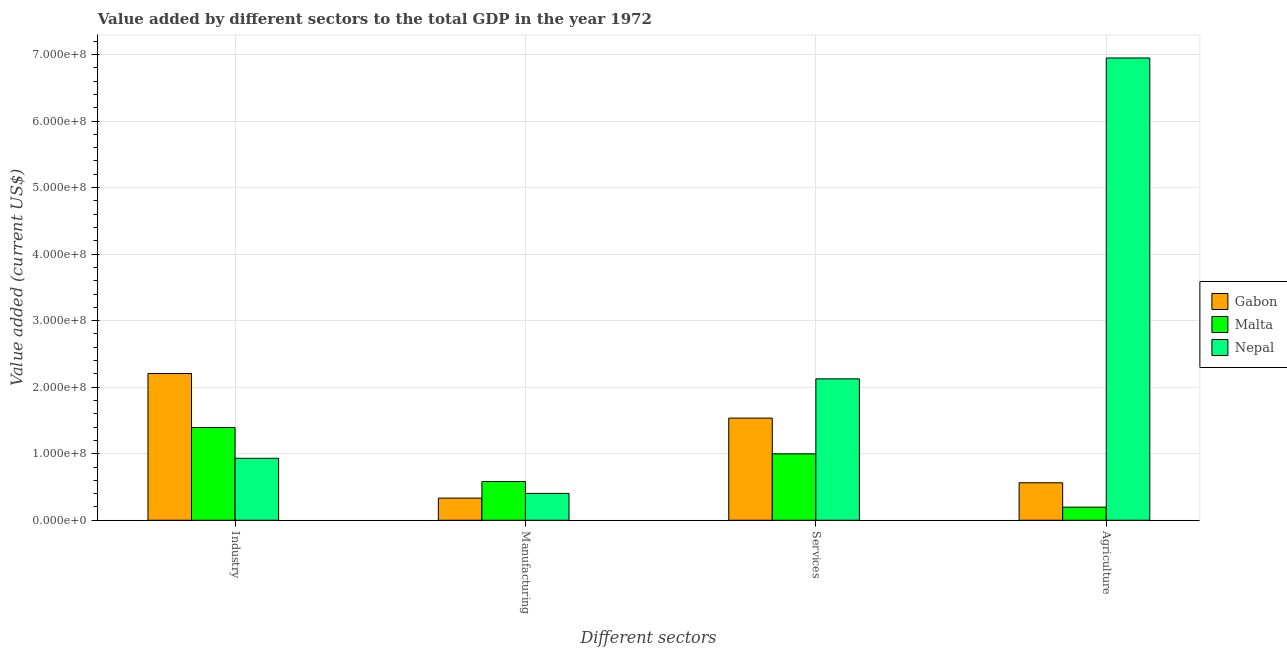Are the number of bars per tick equal to the number of legend labels?
Your response must be concise. Yes. Are the number of bars on each tick of the X-axis equal?
Offer a terse response. Yes. How many bars are there on the 1st tick from the right?
Keep it short and to the point. 3. What is the label of the 3rd group of bars from the left?
Keep it short and to the point. Services. What is the value added by industrial sector in Gabon?
Offer a very short reply. 2.21e+08. Across all countries, what is the maximum value added by services sector?
Your answer should be very brief. 2.13e+08. Across all countries, what is the minimum value added by agricultural sector?
Offer a very short reply. 1.97e+07. In which country was the value added by services sector maximum?
Make the answer very short. Nepal. In which country was the value added by services sector minimum?
Give a very brief answer. Malta. What is the total value added by manufacturing sector in the graph?
Give a very brief answer. 1.32e+08. What is the difference between the value added by manufacturing sector in Malta and that in Gabon?
Keep it short and to the point. 2.49e+07. What is the difference between the value added by manufacturing sector in Gabon and the value added by services sector in Malta?
Your answer should be very brief. -6.65e+07. What is the average value added by services sector per country?
Keep it short and to the point. 1.55e+08. What is the difference between the value added by industrial sector and value added by manufacturing sector in Nepal?
Provide a succinct answer. 5.27e+07. What is the ratio of the value added by manufacturing sector in Gabon to that in Nepal?
Make the answer very short. 0.83. What is the difference between the highest and the second highest value added by industrial sector?
Ensure brevity in your answer.  8.11e+07. What is the difference between the highest and the lowest value added by manufacturing sector?
Ensure brevity in your answer.  2.49e+07. Is the sum of the value added by manufacturing sector in Gabon and Malta greater than the maximum value added by industrial sector across all countries?
Make the answer very short. No. What does the 3rd bar from the left in Agriculture represents?
Keep it short and to the point. Nepal. What does the 2nd bar from the right in Services represents?
Make the answer very short. Malta. Are all the bars in the graph horizontal?
Your answer should be very brief. No. How many countries are there in the graph?
Provide a short and direct response. 3. What is the difference between two consecutive major ticks on the Y-axis?
Keep it short and to the point. 1.00e+08. Where does the legend appear in the graph?
Make the answer very short. Center right. What is the title of the graph?
Provide a succinct answer. Value added by different sectors to the total GDP in the year 1972. Does "Netherlands" appear as one of the legend labels in the graph?
Your answer should be compact. No. What is the label or title of the X-axis?
Your answer should be very brief. Different sectors. What is the label or title of the Y-axis?
Your response must be concise. Value added (current US$). What is the Value added (current US$) in Gabon in Industry?
Provide a short and direct response. 2.21e+08. What is the Value added (current US$) in Malta in Industry?
Provide a short and direct response. 1.39e+08. What is the Value added (current US$) in Nepal in Industry?
Keep it short and to the point. 9.31e+07. What is the Value added (current US$) of Gabon in Manufacturing?
Provide a short and direct response. 3.33e+07. What is the Value added (current US$) of Malta in Manufacturing?
Offer a terse response. 5.83e+07. What is the Value added (current US$) of Nepal in Manufacturing?
Keep it short and to the point. 4.04e+07. What is the Value added (current US$) in Gabon in Services?
Your response must be concise. 1.54e+08. What is the Value added (current US$) in Malta in Services?
Make the answer very short. 9.99e+07. What is the Value added (current US$) in Nepal in Services?
Give a very brief answer. 2.13e+08. What is the Value added (current US$) in Gabon in Agriculture?
Provide a short and direct response. 5.63e+07. What is the Value added (current US$) in Malta in Agriculture?
Offer a very short reply. 1.97e+07. What is the Value added (current US$) in Nepal in Agriculture?
Your response must be concise. 6.95e+08. Across all Different sectors, what is the maximum Value added (current US$) of Gabon?
Keep it short and to the point. 2.21e+08. Across all Different sectors, what is the maximum Value added (current US$) in Malta?
Provide a succinct answer. 1.39e+08. Across all Different sectors, what is the maximum Value added (current US$) in Nepal?
Your answer should be compact. 6.95e+08. Across all Different sectors, what is the minimum Value added (current US$) of Gabon?
Make the answer very short. 3.33e+07. Across all Different sectors, what is the minimum Value added (current US$) of Malta?
Provide a short and direct response. 1.97e+07. Across all Different sectors, what is the minimum Value added (current US$) in Nepal?
Provide a succinct answer. 4.04e+07. What is the total Value added (current US$) in Gabon in the graph?
Offer a very short reply. 4.64e+08. What is the total Value added (current US$) in Malta in the graph?
Offer a terse response. 3.17e+08. What is the total Value added (current US$) in Nepal in the graph?
Provide a short and direct response. 1.04e+09. What is the difference between the Value added (current US$) of Gabon in Industry and that in Manufacturing?
Your answer should be very brief. 1.87e+08. What is the difference between the Value added (current US$) in Malta in Industry and that in Manufacturing?
Provide a succinct answer. 8.12e+07. What is the difference between the Value added (current US$) of Nepal in Industry and that in Manufacturing?
Your answer should be compact. 5.27e+07. What is the difference between the Value added (current US$) in Gabon in Industry and that in Services?
Give a very brief answer. 6.71e+07. What is the difference between the Value added (current US$) of Malta in Industry and that in Services?
Keep it short and to the point. 3.96e+07. What is the difference between the Value added (current US$) of Nepal in Industry and that in Services?
Give a very brief answer. -1.19e+08. What is the difference between the Value added (current US$) of Gabon in Industry and that in Agriculture?
Give a very brief answer. 1.64e+08. What is the difference between the Value added (current US$) in Malta in Industry and that in Agriculture?
Give a very brief answer. 1.20e+08. What is the difference between the Value added (current US$) in Nepal in Industry and that in Agriculture?
Keep it short and to the point. -6.02e+08. What is the difference between the Value added (current US$) in Gabon in Manufacturing and that in Services?
Give a very brief answer. -1.20e+08. What is the difference between the Value added (current US$) of Malta in Manufacturing and that in Services?
Offer a very short reply. -4.16e+07. What is the difference between the Value added (current US$) of Nepal in Manufacturing and that in Services?
Make the answer very short. -1.72e+08. What is the difference between the Value added (current US$) in Gabon in Manufacturing and that in Agriculture?
Ensure brevity in your answer.  -2.30e+07. What is the difference between the Value added (current US$) in Malta in Manufacturing and that in Agriculture?
Ensure brevity in your answer.  3.85e+07. What is the difference between the Value added (current US$) of Nepal in Manufacturing and that in Agriculture?
Make the answer very short. -6.54e+08. What is the difference between the Value added (current US$) of Gabon in Services and that in Agriculture?
Your answer should be very brief. 9.72e+07. What is the difference between the Value added (current US$) in Malta in Services and that in Agriculture?
Ensure brevity in your answer.  8.01e+07. What is the difference between the Value added (current US$) in Nepal in Services and that in Agriculture?
Provide a short and direct response. -4.82e+08. What is the difference between the Value added (current US$) of Gabon in Industry and the Value added (current US$) of Malta in Manufacturing?
Offer a very short reply. 1.62e+08. What is the difference between the Value added (current US$) of Gabon in Industry and the Value added (current US$) of Nepal in Manufacturing?
Provide a short and direct response. 1.80e+08. What is the difference between the Value added (current US$) of Malta in Industry and the Value added (current US$) of Nepal in Manufacturing?
Offer a very short reply. 9.91e+07. What is the difference between the Value added (current US$) in Gabon in Industry and the Value added (current US$) in Malta in Services?
Your answer should be compact. 1.21e+08. What is the difference between the Value added (current US$) of Gabon in Industry and the Value added (current US$) of Nepal in Services?
Your response must be concise. 8.07e+06. What is the difference between the Value added (current US$) in Malta in Industry and the Value added (current US$) in Nepal in Services?
Give a very brief answer. -7.31e+07. What is the difference between the Value added (current US$) of Gabon in Industry and the Value added (current US$) of Malta in Agriculture?
Your answer should be very brief. 2.01e+08. What is the difference between the Value added (current US$) in Gabon in Industry and the Value added (current US$) in Nepal in Agriculture?
Give a very brief answer. -4.74e+08. What is the difference between the Value added (current US$) in Malta in Industry and the Value added (current US$) in Nepal in Agriculture?
Provide a succinct answer. -5.55e+08. What is the difference between the Value added (current US$) of Gabon in Manufacturing and the Value added (current US$) of Malta in Services?
Your answer should be compact. -6.65e+07. What is the difference between the Value added (current US$) in Gabon in Manufacturing and the Value added (current US$) in Nepal in Services?
Your response must be concise. -1.79e+08. What is the difference between the Value added (current US$) of Malta in Manufacturing and the Value added (current US$) of Nepal in Services?
Provide a short and direct response. -1.54e+08. What is the difference between the Value added (current US$) of Gabon in Manufacturing and the Value added (current US$) of Malta in Agriculture?
Your answer should be compact. 1.36e+07. What is the difference between the Value added (current US$) of Gabon in Manufacturing and the Value added (current US$) of Nepal in Agriculture?
Provide a short and direct response. -6.61e+08. What is the difference between the Value added (current US$) of Malta in Manufacturing and the Value added (current US$) of Nepal in Agriculture?
Provide a short and direct response. -6.37e+08. What is the difference between the Value added (current US$) of Gabon in Services and the Value added (current US$) of Malta in Agriculture?
Ensure brevity in your answer.  1.34e+08. What is the difference between the Value added (current US$) of Gabon in Services and the Value added (current US$) of Nepal in Agriculture?
Offer a terse response. -5.41e+08. What is the difference between the Value added (current US$) of Malta in Services and the Value added (current US$) of Nepal in Agriculture?
Ensure brevity in your answer.  -5.95e+08. What is the average Value added (current US$) in Gabon per Different sectors?
Your response must be concise. 1.16e+08. What is the average Value added (current US$) of Malta per Different sectors?
Make the answer very short. 7.93e+07. What is the average Value added (current US$) in Nepal per Different sectors?
Offer a terse response. 2.60e+08. What is the difference between the Value added (current US$) of Gabon and Value added (current US$) of Malta in Industry?
Keep it short and to the point. 8.11e+07. What is the difference between the Value added (current US$) of Gabon and Value added (current US$) of Nepal in Industry?
Ensure brevity in your answer.  1.27e+08. What is the difference between the Value added (current US$) in Malta and Value added (current US$) in Nepal in Industry?
Provide a succinct answer. 4.63e+07. What is the difference between the Value added (current US$) in Gabon and Value added (current US$) in Malta in Manufacturing?
Keep it short and to the point. -2.49e+07. What is the difference between the Value added (current US$) of Gabon and Value added (current US$) of Nepal in Manufacturing?
Ensure brevity in your answer.  -7.07e+06. What is the difference between the Value added (current US$) of Malta and Value added (current US$) of Nepal in Manufacturing?
Your answer should be compact. 1.79e+07. What is the difference between the Value added (current US$) in Gabon and Value added (current US$) in Malta in Services?
Ensure brevity in your answer.  5.37e+07. What is the difference between the Value added (current US$) of Gabon and Value added (current US$) of Nepal in Services?
Ensure brevity in your answer.  -5.90e+07. What is the difference between the Value added (current US$) of Malta and Value added (current US$) of Nepal in Services?
Ensure brevity in your answer.  -1.13e+08. What is the difference between the Value added (current US$) of Gabon and Value added (current US$) of Malta in Agriculture?
Your answer should be compact. 3.66e+07. What is the difference between the Value added (current US$) in Gabon and Value added (current US$) in Nepal in Agriculture?
Provide a succinct answer. -6.38e+08. What is the difference between the Value added (current US$) of Malta and Value added (current US$) of Nepal in Agriculture?
Make the answer very short. -6.75e+08. What is the ratio of the Value added (current US$) of Gabon in Industry to that in Manufacturing?
Keep it short and to the point. 6.62. What is the ratio of the Value added (current US$) of Malta in Industry to that in Manufacturing?
Give a very brief answer. 2.39. What is the ratio of the Value added (current US$) of Nepal in Industry to that in Manufacturing?
Offer a very short reply. 2.31. What is the ratio of the Value added (current US$) of Gabon in Industry to that in Services?
Offer a terse response. 1.44. What is the ratio of the Value added (current US$) in Malta in Industry to that in Services?
Your answer should be very brief. 1.4. What is the ratio of the Value added (current US$) of Nepal in Industry to that in Services?
Provide a succinct answer. 0.44. What is the ratio of the Value added (current US$) of Gabon in Industry to that in Agriculture?
Ensure brevity in your answer.  3.92. What is the ratio of the Value added (current US$) of Malta in Industry to that in Agriculture?
Your response must be concise. 7.07. What is the ratio of the Value added (current US$) in Nepal in Industry to that in Agriculture?
Keep it short and to the point. 0.13. What is the ratio of the Value added (current US$) of Gabon in Manufacturing to that in Services?
Ensure brevity in your answer.  0.22. What is the ratio of the Value added (current US$) in Malta in Manufacturing to that in Services?
Offer a very short reply. 0.58. What is the ratio of the Value added (current US$) of Nepal in Manufacturing to that in Services?
Ensure brevity in your answer.  0.19. What is the ratio of the Value added (current US$) of Gabon in Manufacturing to that in Agriculture?
Keep it short and to the point. 0.59. What is the ratio of the Value added (current US$) in Malta in Manufacturing to that in Agriculture?
Your response must be concise. 2.95. What is the ratio of the Value added (current US$) of Nepal in Manufacturing to that in Agriculture?
Give a very brief answer. 0.06. What is the ratio of the Value added (current US$) of Gabon in Services to that in Agriculture?
Offer a very short reply. 2.73. What is the ratio of the Value added (current US$) of Malta in Services to that in Agriculture?
Your response must be concise. 5.06. What is the ratio of the Value added (current US$) of Nepal in Services to that in Agriculture?
Your answer should be compact. 0.31. What is the difference between the highest and the second highest Value added (current US$) of Gabon?
Give a very brief answer. 6.71e+07. What is the difference between the highest and the second highest Value added (current US$) of Malta?
Your answer should be compact. 3.96e+07. What is the difference between the highest and the second highest Value added (current US$) of Nepal?
Your answer should be very brief. 4.82e+08. What is the difference between the highest and the lowest Value added (current US$) of Gabon?
Give a very brief answer. 1.87e+08. What is the difference between the highest and the lowest Value added (current US$) in Malta?
Your answer should be very brief. 1.20e+08. What is the difference between the highest and the lowest Value added (current US$) in Nepal?
Make the answer very short. 6.54e+08. 